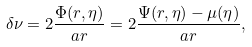Convert formula to latex. <formula><loc_0><loc_0><loc_500><loc_500>\delta \nu = 2 \frac { \Phi ( r , \eta ) } { a r } = 2 \frac { \Psi ( r , \eta ) - \mu ( \eta ) } { a r } ,</formula> 